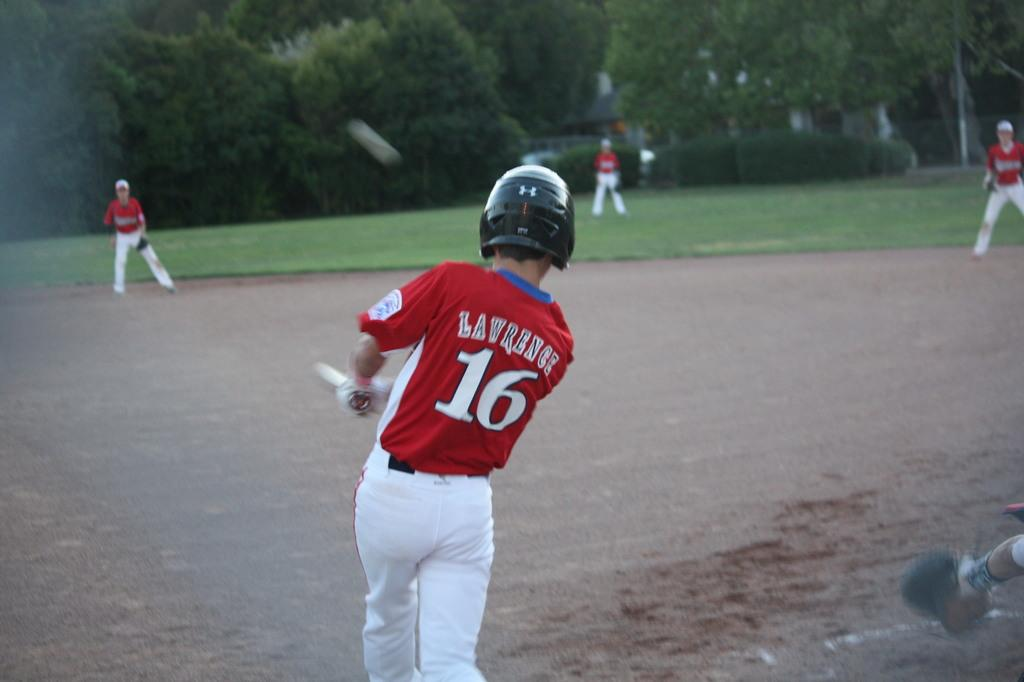<image>
Render a clear and concise summary of the photo. a batter with the number 16 on their jersey 